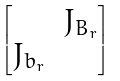Convert formula to latex. <formula><loc_0><loc_0><loc_500><loc_500>\begin{bmatrix} & J _ { B _ { r } } \\ J _ { b _ { r } } & \end{bmatrix}</formula> 